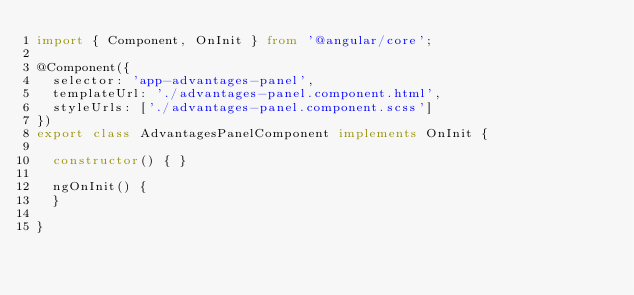Convert code to text. <code><loc_0><loc_0><loc_500><loc_500><_TypeScript_>import { Component, OnInit } from '@angular/core';

@Component({
  selector: 'app-advantages-panel',
  templateUrl: './advantages-panel.component.html',
  styleUrls: ['./advantages-panel.component.scss']
})
export class AdvantagesPanelComponent implements OnInit {

  constructor() { }

  ngOnInit() {
  }

}
</code> 